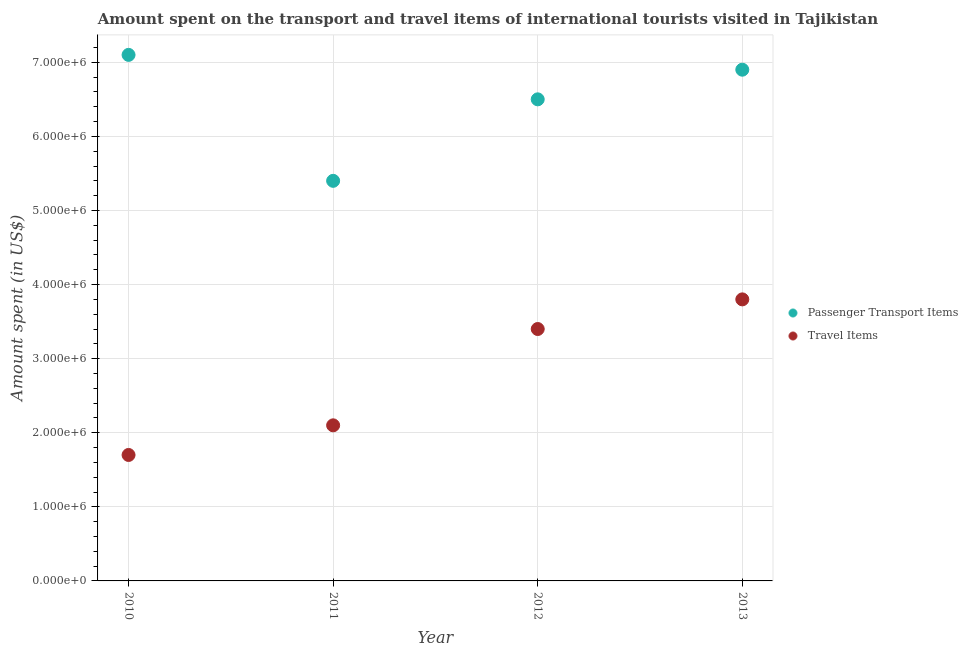Is the number of dotlines equal to the number of legend labels?
Provide a succinct answer. Yes. What is the amount spent on passenger transport items in 2011?
Ensure brevity in your answer.  5.40e+06. Across all years, what is the maximum amount spent in travel items?
Make the answer very short. 3.80e+06. Across all years, what is the minimum amount spent in travel items?
Provide a succinct answer. 1.70e+06. In which year was the amount spent on passenger transport items maximum?
Your response must be concise. 2010. What is the total amount spent in travel items in the graph?
Ensure brevity in your answer.  1.10e+07. What is the difference between the amount spent on passenger transport items in 2010 and that in 2011?
Give a very brief answer. 1.70e+06. What is the difference between the amount spent on passenger transport items in 2010 and the amount spent in travel items in 2012?
Your response must be concise. 3.70e+06. What is the average amount spent in travel items per year?
Provide a short and direct response. 2.75e+06. In the year 2011, what is the difference between the amount spent in travel items and amount spent on passenger transport items?
Offer a terse response. -3.30e+06. In how many years, is the amount spent on passenger transport items greater than 2400000 US$?
Provide a succinct answer. 4. Is the amount spent in travel items in 2011 less than that in 2012?
Keep it short and to the point. Yes. Is the difference between the amount spent in travel items in 2010 and 2012 greater than the difference between the amount spent on passenger transport items in 2010 and 2012?
Your response must be concise. No. What is the difference between the highest and the lowest amount spent in travel items?
Offer a very short reply. 2.10e+06. Is the sum of the amount spent in travel items in 2010 and 2012 greater than the maximum amount spent on passenger transport items across all years?
Keep it short and to the point. No. Is the amount spent on passenger transport items strictly less than the amount spent in travel items over the years?
Provide a succinct answer. No. How many dotlines are there?
Your response must be concise. 2. Are the values on the major ticks of Y-axis written in scientific E-notation?
Provide a succinct answer. Yes. Does the graph contain grids?
Ensure brevity in your answer.  Yes. Where does the legend appear in the graph?
Your response must be concise. Center right. How are the legend labels stacked?
Ensure brevity in your answer.  Vertical. What is the title of the graph?
Offer a very short reply. Amount spent on the transport and travel items of international tourists visited in Tajikistan. What is the label or title of the X-axis?
Give a very brief answer. Year. What is the label or title of the Y-axis?
Your answer should be compact. Amount spent (in US$). What is the Amount spent (in US$) in Passenger Transport Items in 2010?
Your answer should be compact. 7.10e+06. What is the Amount spent (in US$) of Travel Items in 2010?
Give a very brief answer. 1.70e+06. What is the Amount spent (in US$) of Passenger Transport Items in 2011?
Keep it short and to the point. 5.40e+06. What is the Amount spent (in US$) of Travel Items in 2011?
Give a very brief answer. 2.10e+06. What is the Amount spent (in US$) in Passenger Transport Items in 2012?
Your response must be concise. 6.50e+06. What is the Amount spent (in US$) of Travel Items in 2012?
Provide a short and direct response. 3.40e+06. What is the Amount spent (in US$) of Passenger Transport Items in 2013?
Offer a terse response. 6.90e+06. What is the Amount spent (in US$) in Travel Items in 2013?
Provide a short and direct response. 3.80e+06. Across all years, what is the maximum Amount spent (in US$) in Passenger Transport Items?
Your answer should be very brief. 7.10e+06. Across all years, what is the maximum Amount spent (in US$) in Travel Items?
Provide a succinct answer. 3.80e+06. Across all years, what is the minimum Amount spent (in US$) of Passenger Transport Items?
Your answer should be compact. 5.40e+06. Across all years, what is the minimum Amount spent (in US$) of Travel Items?
Your answer should be compact. 1.70e+06. What is the total Amount spent (in US$) of Passenger Transport Items in the graph?
Keep it short and to the point. 2.59e+07. What is the total Amount spent (in US$) of Travel Items in the graph?
Give a very brief answer. 1.10e+07. What is the difference between the Amount spent (in US$) in Passenger Transport Items in 2010 and that in 2011?
Keep it short and to the point. 1.70e+06. What is the difference between the Amount spent (in US$) in Travel Items in 2010 and that in 2011?
Make the answer very short. -4.00e+05. What is the difference between the Amount spent (in US$) of Travel Items in 2010 and that in 2012?
Give a very brief answer. -1.70e+06. What is the difference between the Amount spent (in US$) in Passenger Transport Items in 2010 and that in 2013?
Offer a terse response. 2.00e+05. What is the difference between the Amount spent (in US$) in Travel Items in 2010 and that in 2013?
Your answer should be compact. -2.10e+06. What is the difference between the Amount spent (in US$) of Passenger Transport Items in 2011 and that in 2012?
Your answer should be compact. -1.10e+06. What is the difference between the Amount spent (in US$) in Travel Items in 2011 and that in 2012?
Your answer should be very brief. -1.30e+06. What is the difference between the Amount spent (in US$) in Passenger Transport Items in 2011 and that in 2013?
Your response must be concise. -1.50e+06. What is the difference between the Amount spent (in US$) of Travel Items in 2011 and that in 2013?
Give a very brief answer. -1.70e+06. What is the difference between the Amount spent (in US$) in Passenger Transport Items in 2012 and that in 2013?
Provide a short and direct response. -4.00e+05. What is the difference between the Amount spent (in US$) in Travel Items in 2012 and that in 2013?
Your response must be concise. -4.00e+05. What is the difference between the Amount spent (in US$) in Passenger Transport Items in 2010 and the Amount spent (in US$) in Travel Items in 2012?
Your answer should be compact. 3.70e+06. What is the difference between the Amount spent (in US$) of Passenger Transport Items in 2010 and the Amount spent (in US$) of Travel Items in 2013?
Provide a succinct answer. 3.30e+06. What is the difference between the Amount spent (in US$) of Passenger Transport Items in 2011 and the Amount spent (in US$) of Travel Items in 2013?
Offer a very short reply. 1.60e+06. What is the difference between the Amount spent (in US$) of Passenger Transport Items in 2012 and the Amount spent (in US$) of Travel Items in 2013?
Your answer should be very brief. 2.70e+06. What is the average Amount spent (in US$) in Passenger Transport Items per year?
Keep it short and to the point. 6.48e+06. What is the average Amount spent (in US$) in Travel Items per year?
Give a very brief answer. 2.75e+06. In the year 2010, what is the difference between the Amount spent (in US$) of Passenger Transport Items and Amount spent (in US$) of Travel Items?
Your answer should be compact. 5.40e+06. In the year 2011, what is the difference between the Amount spent (in US$) of Passenger Transport Items and Amount spent (in US$) of Travel Items?
Make the answer very short. 3.30e+06. In the year 2012, what is the difference between the Amount spent (in US$) in Passenger Transport Items and Amount spent (in US$) in Travel Items?
Make the answer very short. 3.10e+06. In the year 2013, what is the difference between the Amount spent (in US$) of Passenger Transport Items and Amount spent (in US$) of Travel Items?
Keep it short and to the point. 3.10e+06. What is the ratio of the Amount spent (in US$) of Passenger Transport Items in 2010 to that in 2011?
Your answer should be compact. 1.31. What is the ratio of the Amount spent (in US$) of Travel Items in 2010 to that in 2011?
Provide a short and direct response. 0.81. What is the ratio of the Amount spent (in US$) of Passenger Transport Items in 2010 to that in 2012?
Provide a succinct answer. 1.09. What is the ratio of the Amount spent (in US$) of Travel Items in 2010 to that in 2013?
Your answer should be very brief. 0.45. What is the ratio of the Amount spent (in US$) of Passenger Transport Items in 2011 to that in 2012?
Your response must be concise. 0.83. What is the ratio of the Amount spent (in US$) in Travel Items in 2011 to that in 2012?
Your response must be concise. 0.62. What is the ratio of the Amount spent (in US$) of Passenger Transport Items in 2011 to that in 2013?
Provide a short and direct response. 0.78. What is the ratio of the Amount spent (in US$) of Travel Items in 2011 to that in 2013?
Provide a short and direct response. 0.55. What is the ratio of the Amount spent (in US$) of Passenger Transport Items in 2012 to that in 2013?
Provide a short and direct response. 0.94. What is the ratio of the Amount spent (in US$) in Travel Items in 2012 to that in 2013?
Make the answer very short. 0.89. What is the difference between the highest and the lowest Amount spent (in US$) in Passenger Transport Items?
Provide a short and direct response. 1.70e+06. What is the difference between the highest and the lowest Amount spent (in US$) in Travel Items?
Provide a short and direct response. 2.10e+06. 